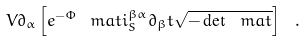<formula> <loc_0><loc_0><loc_500><loc_500>V \partial _ { \alpha } \left [ e ^ { - \Phi } \ m a t i ^ { \beta \alpha } _ { S } \partial _ { \beta } t \sqrt { - \det \ m a t } \right ] \ .</formula> 